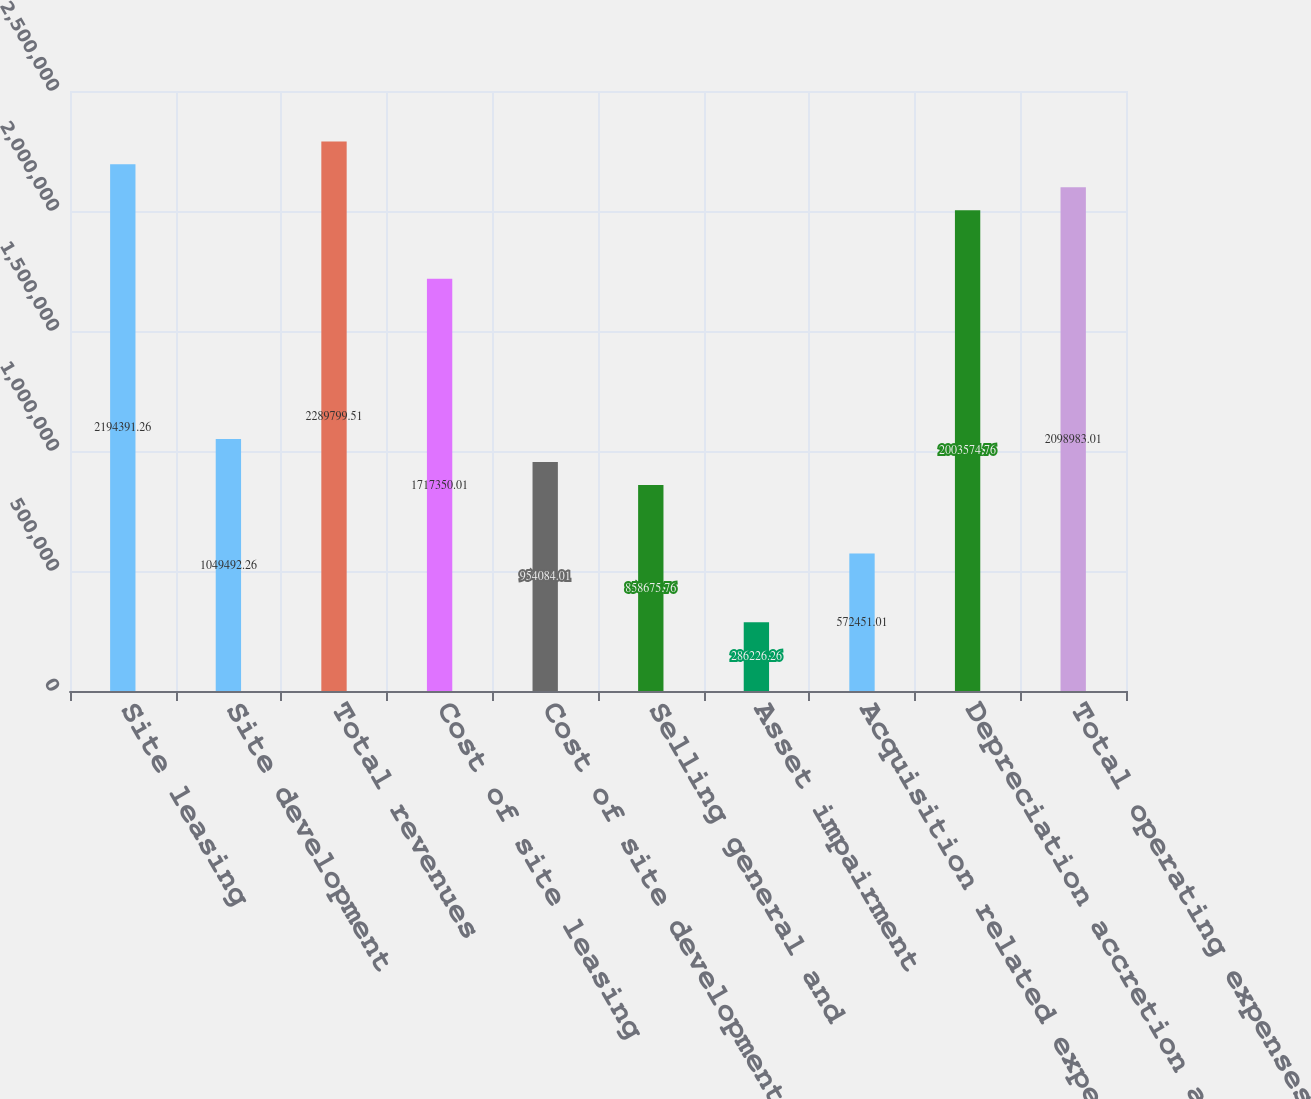Convert chart. <chart><loc_0><loc_0><loc_500><loc_500><bar_chart><fcel>Site leasing<fcel>Site development<fcel>Total revenues<fcel>Cost of site leasing<fcel>Cost of site development<fcel>Selling general and<fcel>Asset impairment<fcel>Acquisition related expenses<fcel>Depreciation accretion and<fcel>Total operating expenses<nl><fcel>2.19439e+06<fcel>1.04949e+06<fcel>2.2898e+06<fcel>1.71735e+06<fcel>954084<fcel>858676<fcel>286226<fcel>572451<fcel>2.00357e+06<fcel>2.09898e+06<nl></chart> 